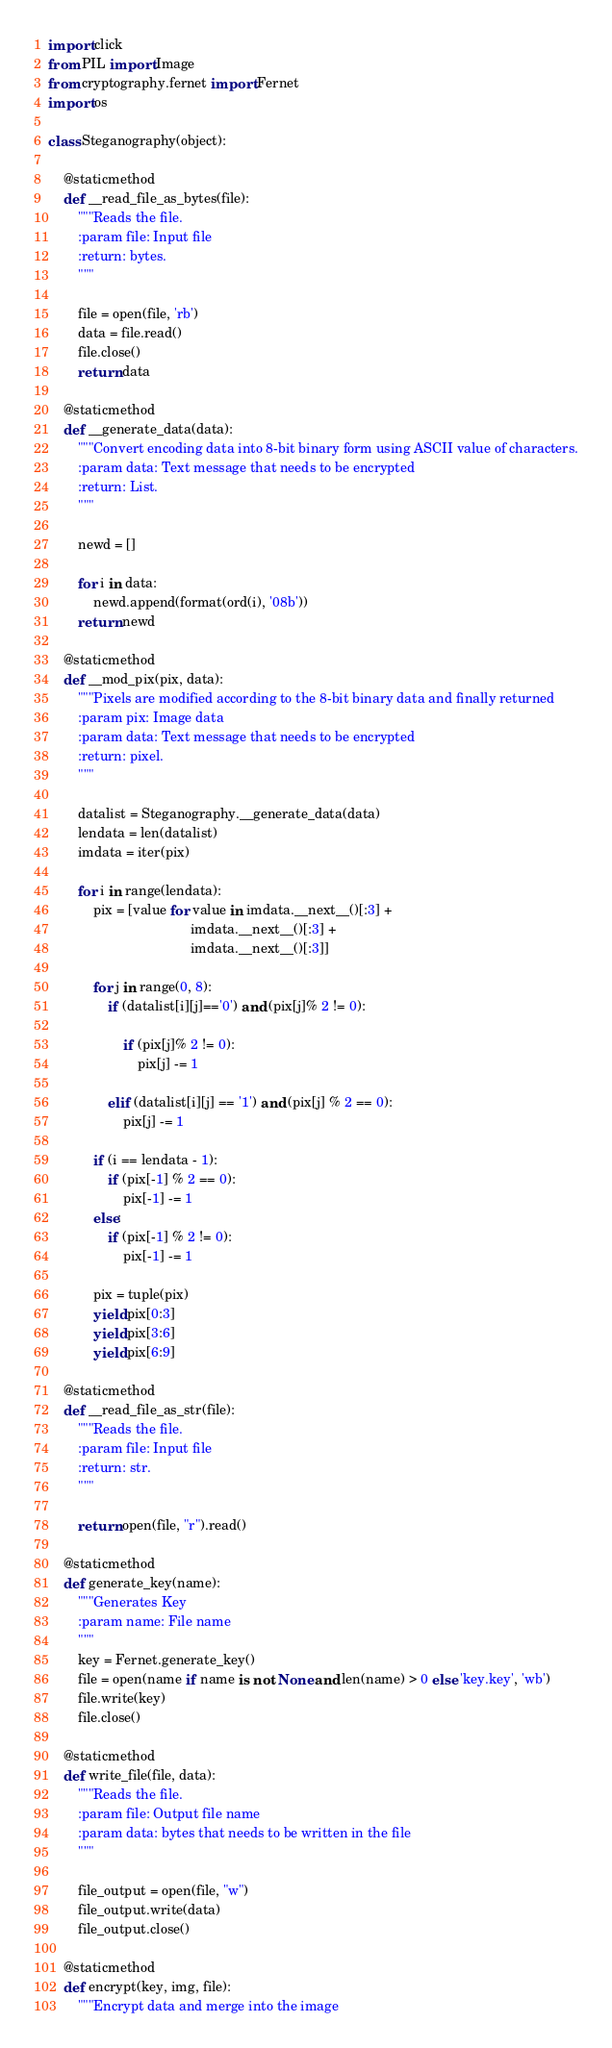Convert code to text. <code><loc_0><loc_0><loc_500><loc_500><_Python_>import click
from PIL import Image
from cryptography.fernet import Fernet
import os

class Steganography(object):

    @staticmethod
    def __read_file_as_bytes(file):
        """Reads the file.
        :param file: Input file
        :return: bytes.
        """
        
        file = open(file, 'rb')
        data = file.read()
        file.close()
        return data

    @staticmethod
    def __generate_data(data):
        """Convert encoding data into 8-bit binary form using ASCII value of characters.
        :param data: Text message that needs to be encrypted
        :return: List.
        """
        
        newd = []  
          
        for i in data:
            newd.append(format(ord(i), '08b')) 
        return newd 
                
    @staticmethod
    def __mod_pix(pix, data):
        """Pixels are modified according to the 8-bit binary data and finally returned
        :param pix: Image data
        :param data: Text message that needs to be encrypted
        :return: pixel.
        """

        datalist = Steganography.__generate_data(data) 
        lendata = len(datalist) 
        imdata = iter(pix) 
    
        for i in range(lendata): 
            pix = [value for value in imdata.__next__()[:3] +
                                      imdata.__next__()[:3] +
                                      imdata.__next__()[:3]] 

            for j in range(0, 8): 
                if (datalist[i][j]=='0') and (pix[j]% 2 != 0): 

                    if (pix[j]% 2 != 0): 
                        pix[j] -= 1

                elif (datalist[i][j] == '1') and (pix[j] % 2 == 0): 
                    pix[j] -= 1
 
            if (i == lendata - 1): 
                if (pix[-1] % 2 == 0): 
                    pix[-1] -= 1
            else: 
                if (pix[-1] % 2 != 0): 
                    pix[-1] -= 1
    
            pix = tuple(pix) 
            yield pix[0:3] 
            yield pix[3:6] 
            yield pix[6:9]

    @staticmethod
    def __read_file_as_str(file):
        """Reads the file.
        :param file: Input file
        :return: str.
        """
        
        return open(file, "r").read()

    @staticmethod
    def generate_key(name):
        """Generates Key
        :param name: File name
        """
        key = Fernet.generate_key()
        file = open(name if name is not None and len(name) > 0 else 'key.key', 'wb')
        file.write(key)
        file.close()

    @staticmethod
    def write_file(file, data):
        """Reads the file.
        :param file: Output file name
        :param data: bytes that needs to be written in the file
        """
        
        file_output = open(file, "w")
        file_output.write(data)
        file_output.close()

    @staticmethod
    def encrypt(key, img, file):
        """Encrypt data and merge into the image</code> 